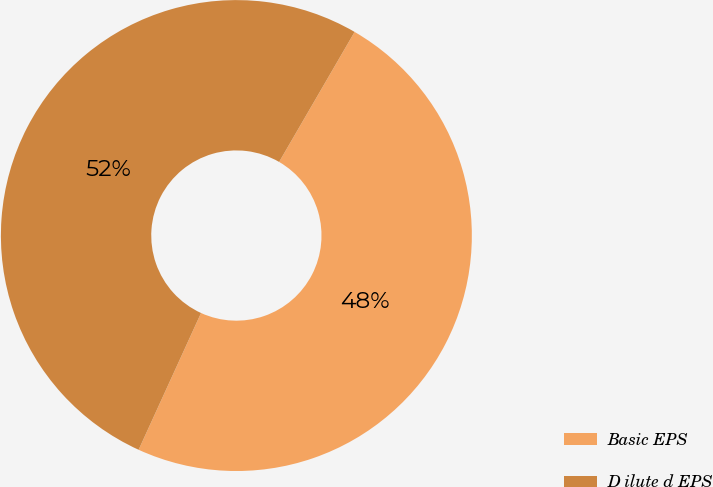Convert chart. <chart><loc_0><loc_0><loc_500><loc_500><pie_chart><fcel>Basic EPS<fcel>D ilute d EPS<nl><fcel>48.44%<fcel>51.56%<nl></chart> 